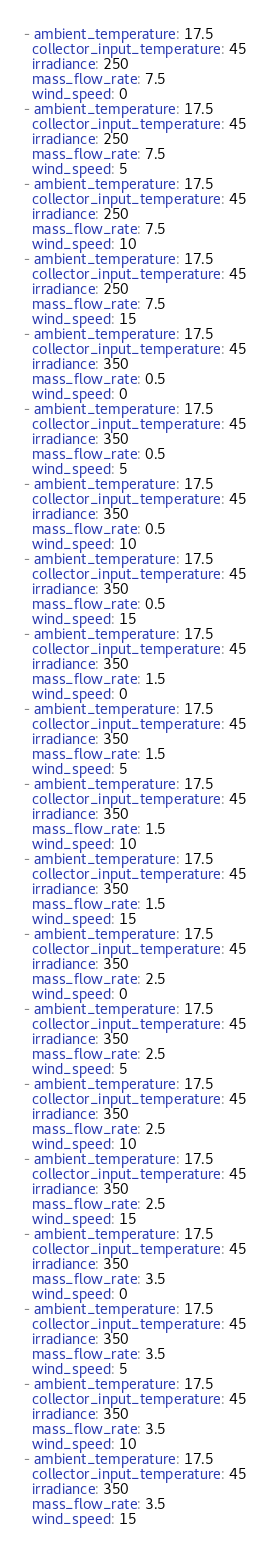<code> <loc_0><loc_0><loc_500><loc_500><_YAML_>- ambient_temperature: 17.5
  collector_input_temperature: 45
  irradiance: 250
  mass_flow_rate: 7.5
  wind_speed: 0
- ambient_temperature: 17.5
  collector_input_temperature: 45
  irradiance: 250
  mass_flow_rate: 7.5
  wind_speed: 5
- ambient_temperature: 17.5
  collector_input_temperature: 45
  irradiance: 250
  mass_flow_rate: 7.5
  wind_speed: 10
- ambient_temperature: 17.5
  collector_input_temperature: 45
  irradiance: 250
  mass_flow_rate: 7.5
  wind_speed: 15
- ambient_temperature: 17.5
  collector_input_temperature: 45
  irradiance: 350
  mass_flow_rate: 0.5
  wind_speed: 0
- ambient_temperature: 17.5
  collector_input_temperature: 45
  irradiance: 350
  mass_flow_rate: 0.5
  wind_speed: 5
- ambient_temperature: 17.5
  collector_input_temperature: 45
  irradiance: 350
  mass_flow_rate: 0.5
  wind_speed: 10
- ambient_temperature: 17.5
  collector_input_temperature: 45
  irradiance: 350
  mass_flow_rate: 0.5
  wind_speed: 15
- ambient_temperature: 17.5
  collector_input_temperature: 45
  irradiance: 350
  mass_flow_rate: 1.5
  wind_speed: 0
- ambient_temperature: 17.5
  collector_input_temperature: 45
  irradiance: 350
  mass_flow_rate: 1.5
  wind_speed: 5
- ambient_temperature: 17.5
  collector_input_temperature: 45
  irradiance: 350
  mass_flow_rate: 1.5
  wind_speed: 10
- ambient_temperature: 17.5
  collector_input_temperature: 45
  irradiance: 350
  mass_flow_rate: 1.5
  wind_speed: 15
- ambient_temperature: 17.5
  collector_input_temperature: 45
  irradiance: 350
  mass_flow_rate: 2.5
  wind_speed: 0
- ambient_temperature: 17.5
  collector_input_temperature: 45
  irradiance: 350
  mass_flow_rate: 2.5
  wind_speed: 5
- ambient_temperature: 17.5
  collector_input_temperature: 45
  irradiance: 350
  mass_flow_rate: 2.5
  wind_speed: 10
- ambient_temperature: 17.5
  collector_input_temperature: 45
  irradiance: 350
  mass_flow_rate: 2.5
  wind_speed: 15
- ambient_temperature: 17.5
  collector_input_temperature: 45
  irradiance: 350
  mass_flow_rate: 3.5
  wind_speed: 0
- ambient_temperature: 17.5
  collector_input_temperature: 45
  irradiance: 350
  mass_flow_rate: 3.5
  wind_speed: 5
- ambient_temperature: 17.5
  collector_input_temperature: 45
  irradiance: 350
  mass_flow_rate: 3.5
  wind_speed: 10
- ambient_temperature: 17.5
  collector_input_temperature: 45
  irradiance: 350
  mass_flow_rate: 3.5
  wind_speed: 15
</code> 